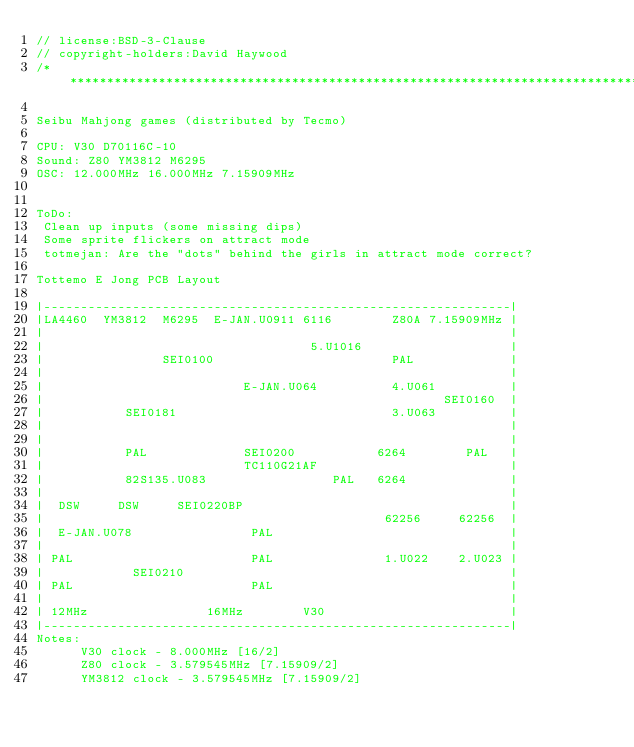Convert code to text. <code><loc_0><loc_0><loc_500><loc_500><_C++_>// license:BSD-3-Clause
// copyright-holders:David Haywood
/******************************************************************************************

Seibu Mahjong games (distributed by Tecmo)

CPU: V30 D70116C-10
Sound: Z80 YM3812 M6295
OSC: 12.000MHz 16.000MHz 7.15909MHz


ToDo:
 Clean up inputs (some missing dips)
 Some sprite flickers on attract mode
 totmejan: Are the "dots" behind the girls in attract mode correct?

Tottemo E Jong PCB Layout

|---------------------------------------------------------------|
|LA4460  YM3812  M6295  E-JAN.U0911 6116        Z80A 7.15909MHz |
|                                                               |
|                                    5.U1016                    |
|                SEI0100                        PAL             |
|                                                               |
|                           E-JAN.U064          4.U061          |
|                                                      SEI0160  |
|           SEI0181                             3.U063          |
|                                                               |
|                                                               |
|           PAL             SEI0200           6264        PAL   |
|                           TC110G21AF                          |
|           82S135.U083                 PAL   6264              |
|                                                               |
|  DSW     DSW     SEI0220BP                                    |
|                                              62256     62256  |
|  E-JAN.U078                PAL                                |
|                                                               |
| PAL                        PAL               1.U022    2.U023 |
|            SEI0210                                            |
| PAL                        PAL                                |
|                                                               |
| 12MHz                16MHz        V30                         |
|---------------------------------------------------------------|
Notes:
      V30 clock - 8.000MHz [16/2]
      Z80 clock - 3.579545MHz [7.15909/2]
      YM3812 clock - 3.579545MHz [7.15909/2]</code> 